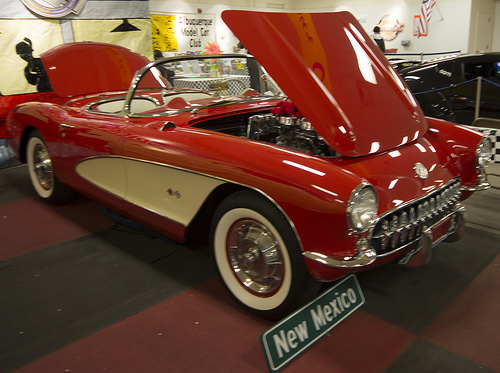<image>
Can you confirm if the wheel is next to the car? No. The wheel is not positioned next to the car. They are located in different areas of the scene. 